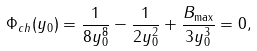<formula> <loc_0><loc_0><loc_500><loc_500>\Phi _ { c h } ( y _ { 0 } ) = \frac { 1 } { 8 y _ { 0 } ^ { 8 } } - \frac { 1 } { 2 y _ { 0 } ^ { 2 } } + \frac { B _ { \max } } { 3 y _ { 0 } ^ { 3 } } = 0 ,</formula> 